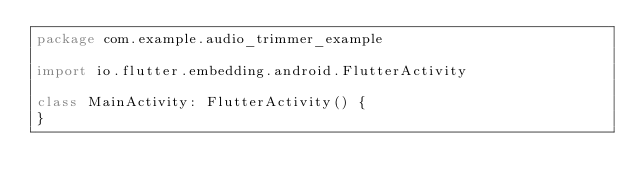Convert code to text. <code><loc_0><loc_0><loc_500><loc_500><_Kotlin_>package com.example.audio_trimmer_example

import io.flutter.embedding.android.FlutterActivity

class MainActivity: FlutterActivity() {
}
</code> 